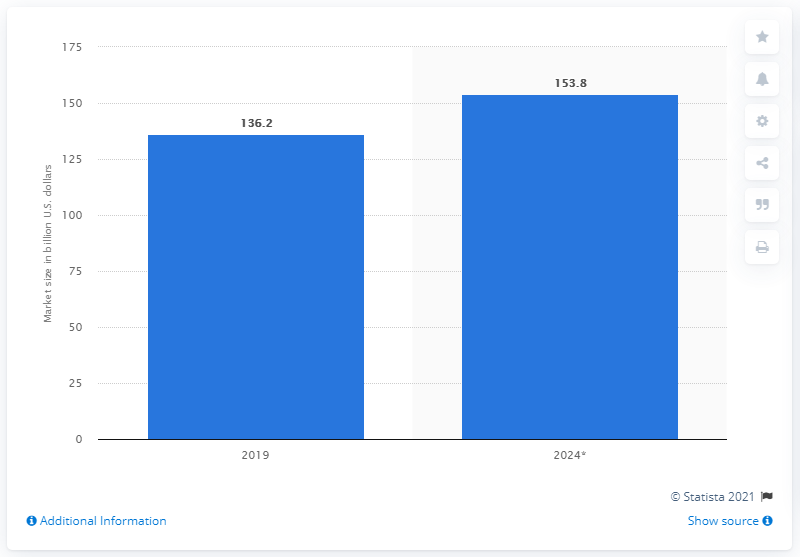Indicate a few pertinent items in this graphic. The value of biofuels was significantly different, with a difference of 17.6% between the two scenarios. The global biofuels market was valued at approximately 136.2 billion dollars in 2019. In 2024, biofuels were highly valued. 